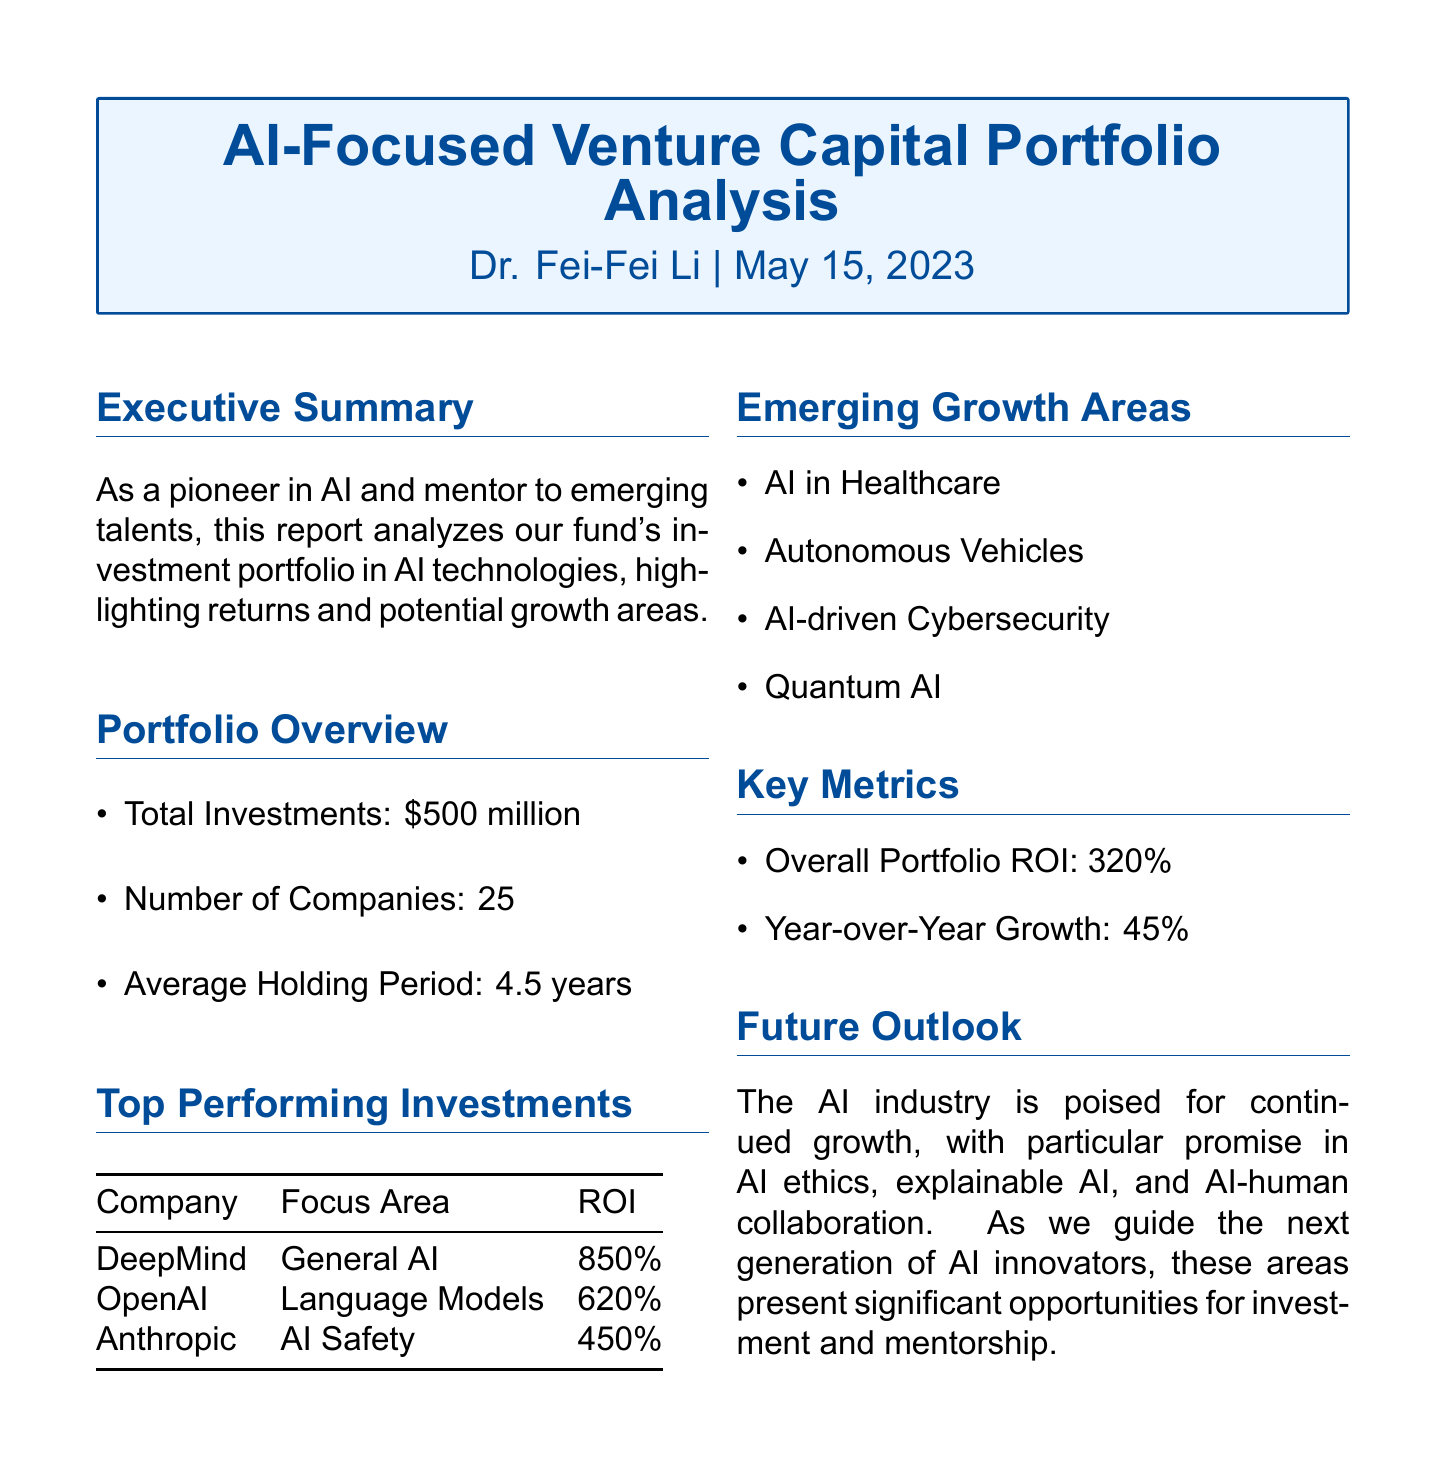What is the title of the report? The title is often highlighted at the beginning of the document, which is "AI-Focused Venture Capital Portfolio Analysis."
Answer: AI-Focused Venture Capital Portfolio Analysis Who is the author of the report? The author is mentioned prominently in the document, which is Dr. Fei-Fei Li.
Answer: Dr. Fei-Fei Li What is the total amount of investments? The document specifies the total amount of investments in the portfolio as "$500 million."
Answer: $500 million What is the year-over-year growth percentage? The year-over-year growth metric is directly stated in the report as "45%."
Answer: 45% Which company has the highest return on investment? The company with the highest ROI is detailed in the "Top Performing Investments" section, which is DeepMind.
Answer: DeepMind How many companies are in the investment portfolio? The total number of companies is mentioned in the "Portfolio Overview" section, which is 25.
Answer: 25 What is the overall portfolio ROI? The overall ROI is specifically stated in the document as "320%."
Answer: 320% Name one emerging growth area in AI. The report lists several growth areas; one example is "AI in Healthcare."
Answer: AI in Healthcare What is the average holding period for investments? The average holding period is indicated in the "Portfolio Overview" section as "4.5 years."
Answer: 4.5 years 